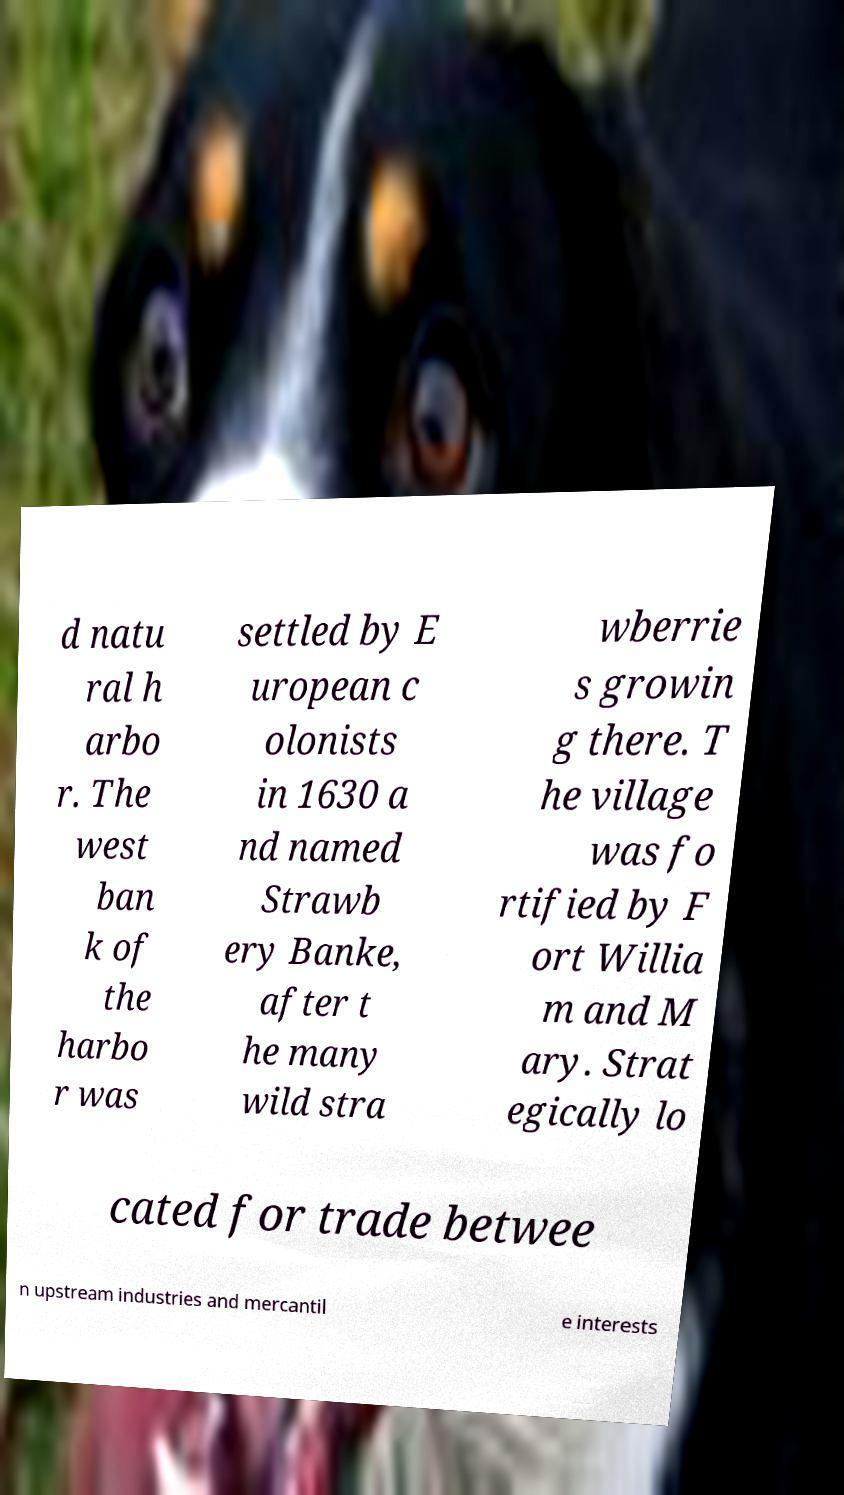There's text embedded in this image that I need extracted. Can you transcribe it verbatim? d natu ral h arbo r. The west ban k of the harbo r was settled by E uropean c olonists in 1630 a nd named Strawb ery Banke, after t he many wild stra wberrie s growin g there. T he village was fo rtified by F ort Willia m and M ary. Strat egically lo cated for trade betwee n upstream industries and mercantil e interests 